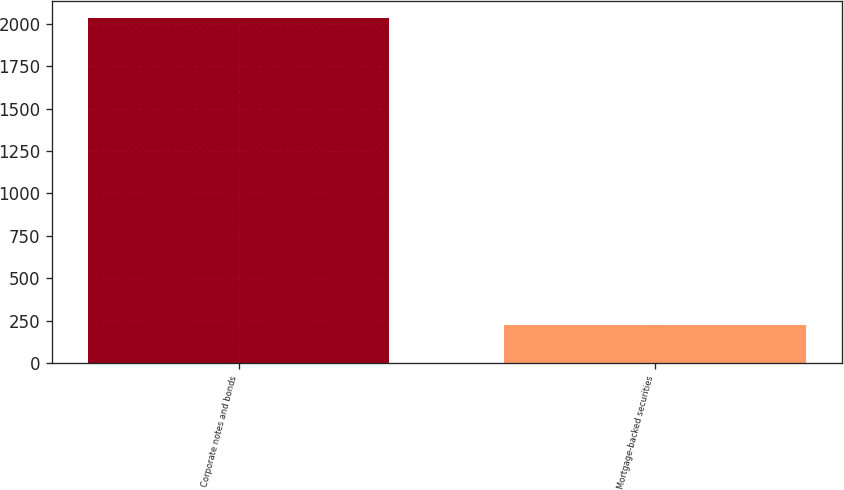Convert chart. <chart><loc_0><loc_0><loc_500><loc_500><bar_chart><fcel>Corporate notes and bonds<fcel>Mortgage-backed securities<nl><fcel>2032<fcel>223<nl></chart> 